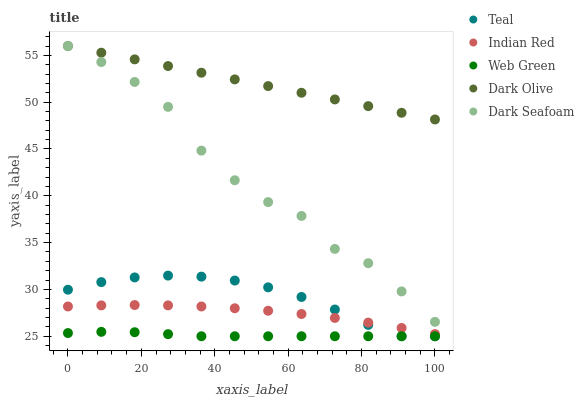Does Web Green have the minimum area under the curve?
Answer yes or no. Yes. Does Dark Olive have the maximum area under the curve?
Answer yes or no. Yes. Does Dark Seafoam have the minimum area under the curve?
Answer yes or no. No. Does Dark Seafoam have the maximum area under the curve?
Answer yes or no. No. Is Dark Olive the smoothest?
Answer yes or no. Yes. Is Dark Seafoam the roughest?
Answer yes or no. Yes. Is Web Green the smoothest?
Answer yes or no. No. Is Web Green the roughest?
Answer yes or no. No. Does Web Green have the lowest value?
Answer yes or no. Yes. Does Dark Seafoam have the lowest value?
Answer yes or no. No. Does Dark Seafoam have the highest value?
Answer yes or no. Yes. Does Web Green have the highest value?
Answer yes or no. No. Is Teal less than Dark Seafoam?
Answer yes or no. Yes. Is Dark Seafoam greater than Indian Red?
Answer yes or no. Yes. Does Teal intersect Indian Red?
Answer yes or no. Yes. Is Teal less than Indian Red?
Answer yes or no. No. Is Teal greater than Indian Red?
Answer yes or no. No. Does Teal intersect Dark Seafoam?
Answer yes or no. No. 